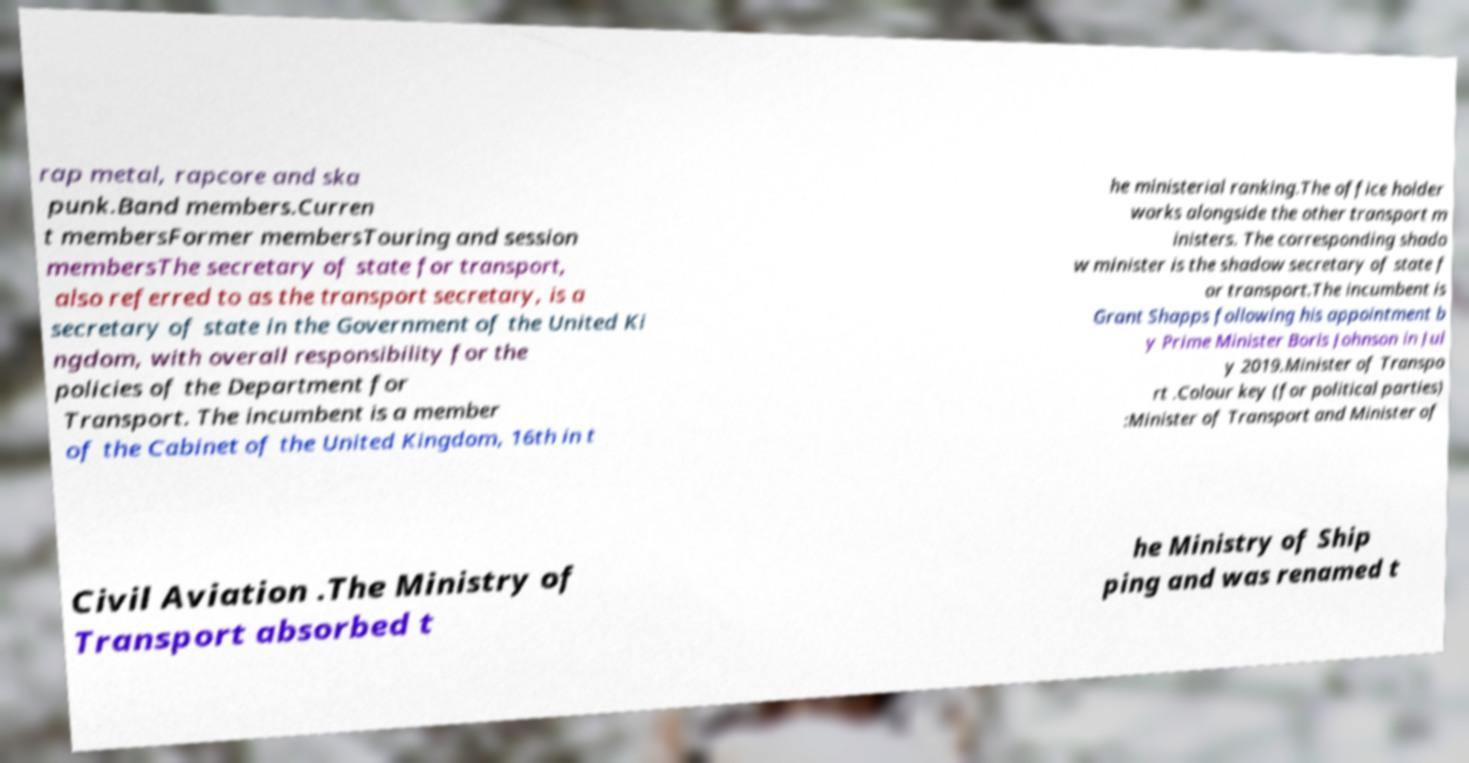Please read and relay the text visible in this image. What does it say? rap metal, rapcore and ska punk.Band members.Curren t membersFormer membersTouring and session membersThe secretary of state for transport, also referred to as the transport secretary, is a secretary of state in the Government of the United Ki ngdom, with overall responsibility for the policies of the Department for Transport. The incumbent is a member of the Cabinet of the United Kingdom, 16th in t he ministerial ranking.The office holder works alongside the other transport m inisters. The corresponding shado w minister is the shadow secretary of state f or transport.The incumbent is Grant Shapps following his appointment b y Prime Minister Boris Johnson in Jul y 2019.Minister of Transpo rt .Colour key (for political parties) :Minister of Transport and Minister of Civil Aviation .The Ministry of Transport absorbed t he Ministry of Ship ping and was renamed t 